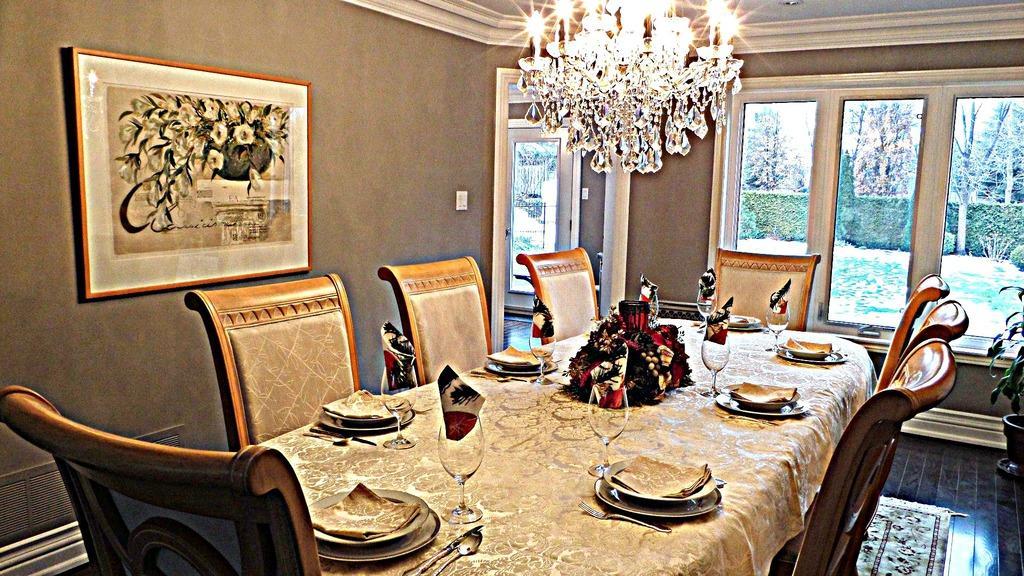Can you describe this image briefly? In this image we can see an inside view of a room. In the middle of the image we can see a table on which group of glasses, plates, spoons, flowers are placed and group of chairs on the ground. To the right side of the image we can see a plant. To the left side of the image we can see a photo frame on the wall. In the background, we can see a chandelier windows and a group of trees. 